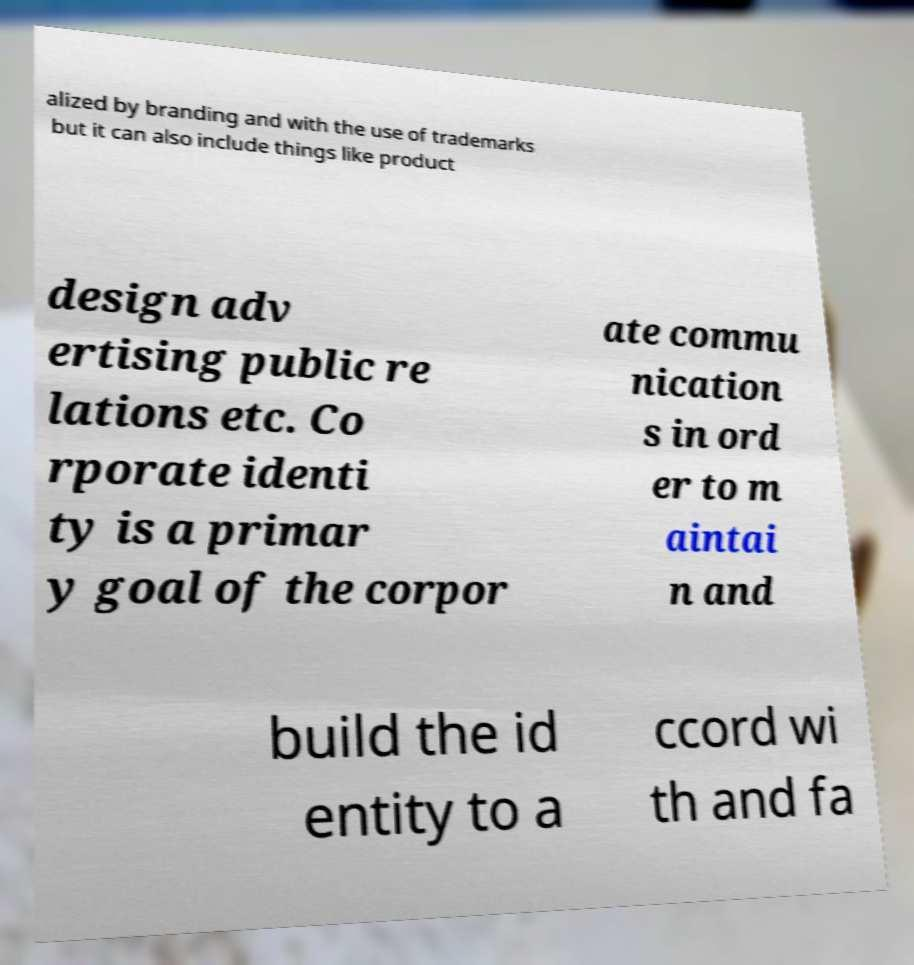For documentation purposes, I need the text within this image transcribed. Could you provide that? alized by branding and with the use of trademarks but it can also include things like product design adv ertising public re lations etc. Co rporate identi ty is a primar y goal of the corpor ate commu nication s in ord er to m aintai n and build the id entity to a ccord wi th and fa 